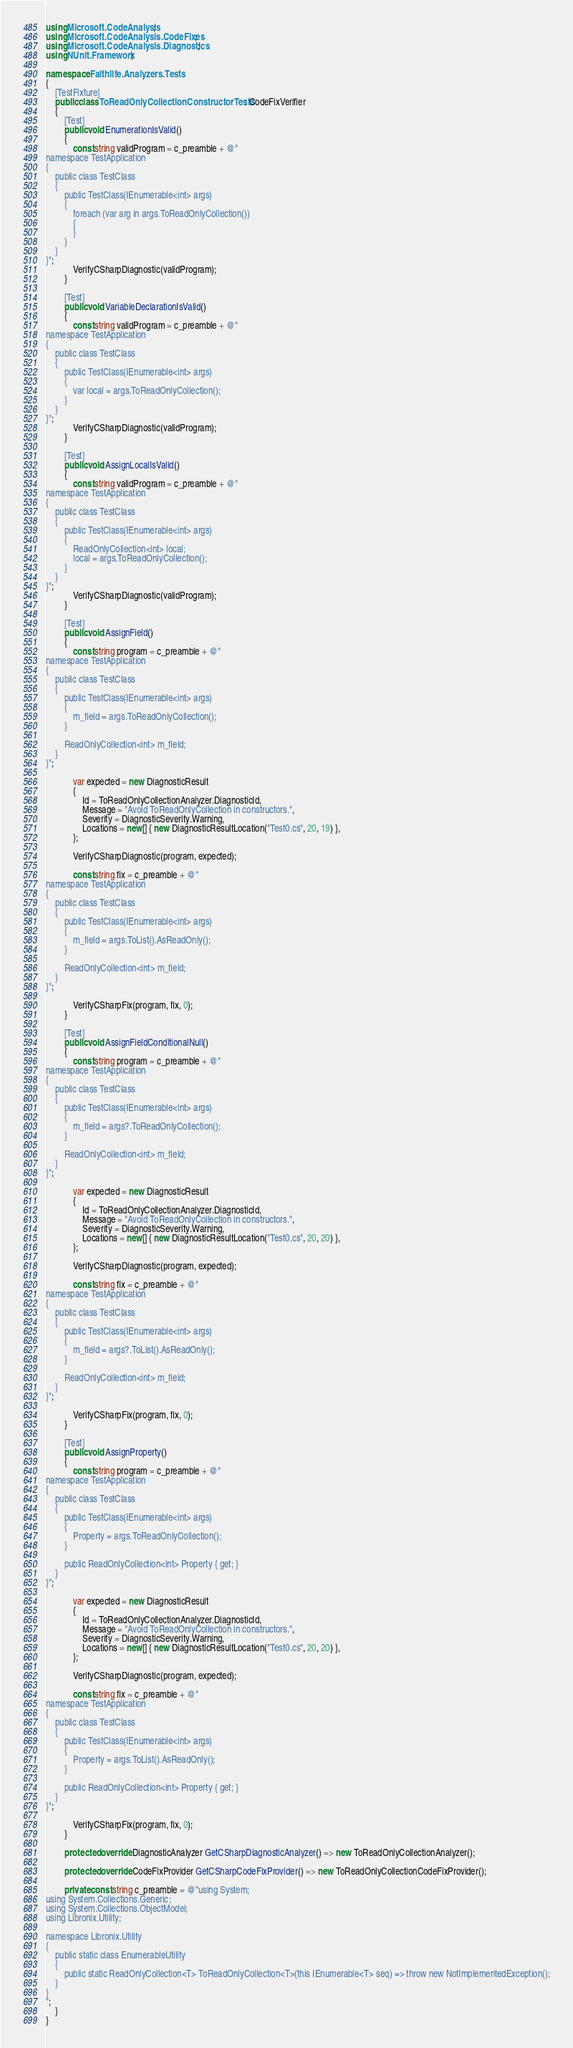<code> <loc_0><loc_0><loc_500><loc_500><_C#_>using Microsoft.CodeAnalysis;
using Microsoft.CodeAnalysis.CodeFixes;
using Microsoft.CodeAnalysis.Diagnostics;
using NUnit.Framework;

namespace Faithlife.Analyzers.Tests
{
	[TestFixture]
	public class ToReadOnlyCollectionConstructorTests : CodeFixVerifier
	{
		[Test]
		public void EnumerationIsValid()
		{
			const string validProgram = c_preamble + @"
namespace TestApplication
{
	public class TestClass
	{
		public TestClass(IEnumerable<int> args)
		{
			foreach (var arg in args.ToReadOnlyCollection())
			{
			}
		}
	}
}";
			VerifyCSharpDiagnostic(validProgram);
		}

		[Test]
		public void VariableDeclarationIsValid()
		{
			const string validProgram = c_preamble + @"
namespace TestApplication
{
	public class TestClass
	{
		public TestClass(IEnumerable<int> args)
		{
			var local = args.ToReadOnlyCollection();
		}
	}
}";
			VerifyCSharpDiagnostic(validProgram);
		}

		[Test]
		public void AssignLocalIsValid()
		{
			const string validProgram = c_preamble + @"
namespace TestApplication
{
	public class TestClass
	{
		public TestClass(IEnumerable<int> args)
		{
			ReadOnlyCollection<int> local;
			local = args.ToReadOnlyCollection();
		}
	}
}";
			VerifyCSharpDiagnostic(validProgram);
		}

		[Test]
		public void AssignField()
		{
			const string program = c_preamble + @"
namespace TestApplication
{
	public class TestClass
	{
		public TestClass(IEnumerable<int> args)
		{
			m_field = args.ToReadOnlyCollection();
		}

		ReadOnlyCollection<int> m_field;
	}
}";

			var expected = new DiagnosticResult
			{
				Id = ToReadOnlyCollectionAnalyzer.DiagnosticId,
				Message = "Avoid ToReadOnlyCollection in constructors.",
				Severity = DiagnosticSeverity.Warning,
				Locations = new[] { new DiagnosticResultLocation("Test0.cs", 20, 19) },
			};

			VerifyCSharpDiagnostic(program, expected);

			const string fix = c_preamble + @"
namespace TestApplication
{
	public class TestClass
	{
		public TestClass(IEnumerable<int> args)
		{
			m_field = args.ToList().AsReadOnly();
		}

		ReadOnlyCollection<int> m_field;
	}
}";

			VerifyCSharpFix(program, fix, 0);
		}

		[Test]
		public void AssignFieldConditionalNull()
		{
			const string program = c_preamble + @"
namespace TestApplication
{
	public class TestClass
	{
		public TestClass(IEnumerable<int> args)
		{
			m_field = args?.ToReadOnlyCollection();
		}

		ReadOnlyCollection<int> m_field;
	}
}";

			var expected = new DiagnosticResult
			{
				Id = ToReadOnlyCollectionAnalyzer.DiagnosticId,
				Message = "Avoid ToReadOnlyCollection in constructors.",
				Severity = DiagnosticSeverity.Warning,
				Locations = new[] { new DiagnosticResultLocation("Test0.cs", 20, 20) },
			};

			VerifyCSharpDiagnostic(program, expected);

			const string fix = c_preamble + @"
namespace TestApplication
{
	public class TestClass
	{
		public TestClass(IEnumerable<int> args)
		{
			m_field = args?.ToList().AsReadOnly();
		}

		ReadOnlyCollection<int> m_field;
	}
}";

			VerifyCSharpFix(program, fix, 0);
		}

		[Test]
		public void AssignProperty()
		{
			const string program = c_preamble + @"
namespace TestApplication
{
	public class TestClass
	{
		public TestClass(IEnumerable<int> args)
		{
			Property = args.ToReadOnlyCollection();
		}

		public ReadOnlyCollection<int> Property { get; }
	}
}";

			var expected = new DiagnosticResult
			{
				Id = ToReadOnlyCollectionAnalyzer.DiagnosticId,
				Message = "Avoid ToReadOnlyCollection in constructors.",
				Severity = DiagnosticSeverity.Warning,
				Locations = new[] { new DiagnosticResultLocation("Test0.cs", 20, 20) },
			};

			VerifyCSharpDiagnostic(program, expected);

			const string fix = c_preamble + @"
namespace TestApplication
{
	public class TestClass
	{
		public TestClass(IEnumerable<int> args)
		{
			Property = args.ToList().AsReadOnly();
		}

		public ReadOnlyCollection<int> Property { get; }
	}
}";

			VerifyCSharpFix(program, fix, 0);
		}

		protected override DiagnosticAnalyzer GetCSharpDiagnosticAnalyzer() => new ToReadOnlyCollectionAnalyzer();

		protected override CodeFixProvider GetCSharpCodeFixProvider() => new ToReadOnlyCollectionCodeFixProvider();

		private const string c_preamble = @"using System;
using System.Collections.Generic;
using System.Collections.ObjectModel;
using Libronix.Utility;

namespace Libronix.Utility
{
	public static class EnumerableUtility
	{
		public static ReadOnlyCollection<T> ToReadOnlyCollection<T>(this IEnumerable<T> seq) => throw new NotImplementedException();
	}
}
";
	}
}
</code> 